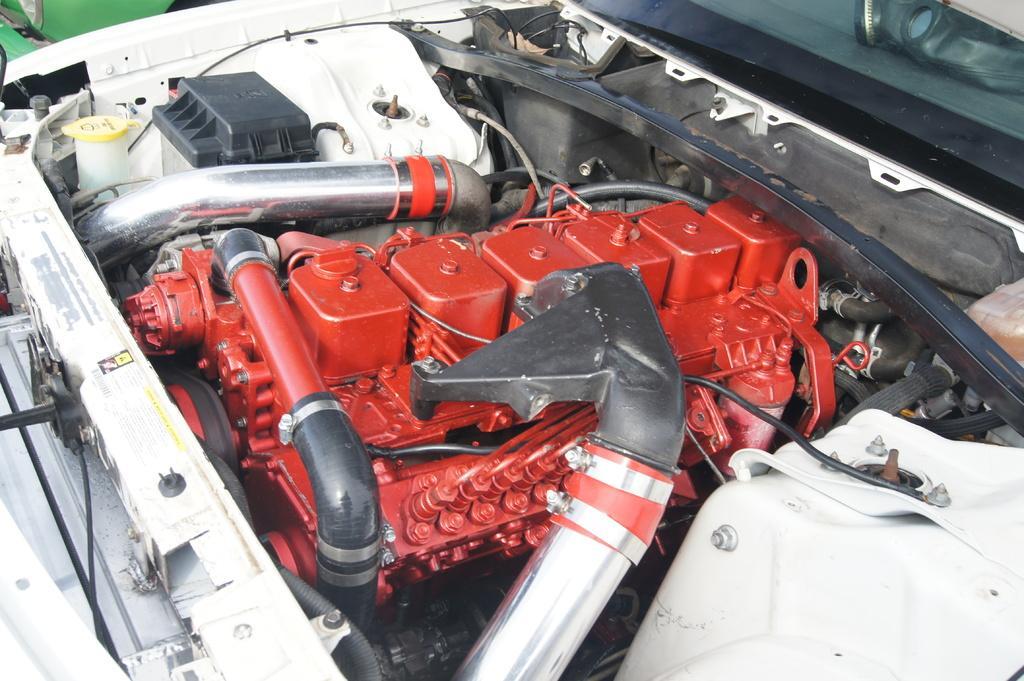Can you describe this image briefly? In the image we can see the vehicle engine. 